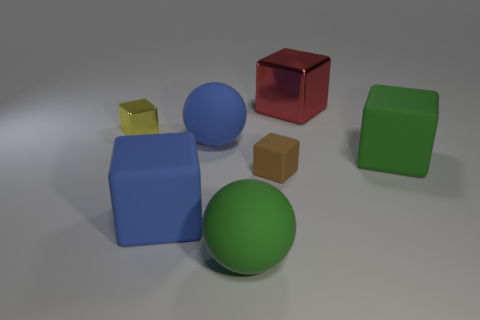Subtract all large blue blocks. How many blocks are left? 4 Subtract all blue cubes. How many cubes are left? 4 Subtract all cubes. How many objects are left? 2 Add 3 brown things. How many objects exist? 10 Subtract 2 cubes. How many cubes are left? 3 Subtract 0 red balls. How many objects are left? 7 Subtract all yellow blocks. Subtract all red cylinders. How many blocks are left? 4 Subtract all brown cylinders. How many blue spheres are left? 1 Subtract all large yellow rubber cubes. Subtract all balls. How many objects are left? 5 Add 2 large matte cubes. How many large matte cubes are left? 4 